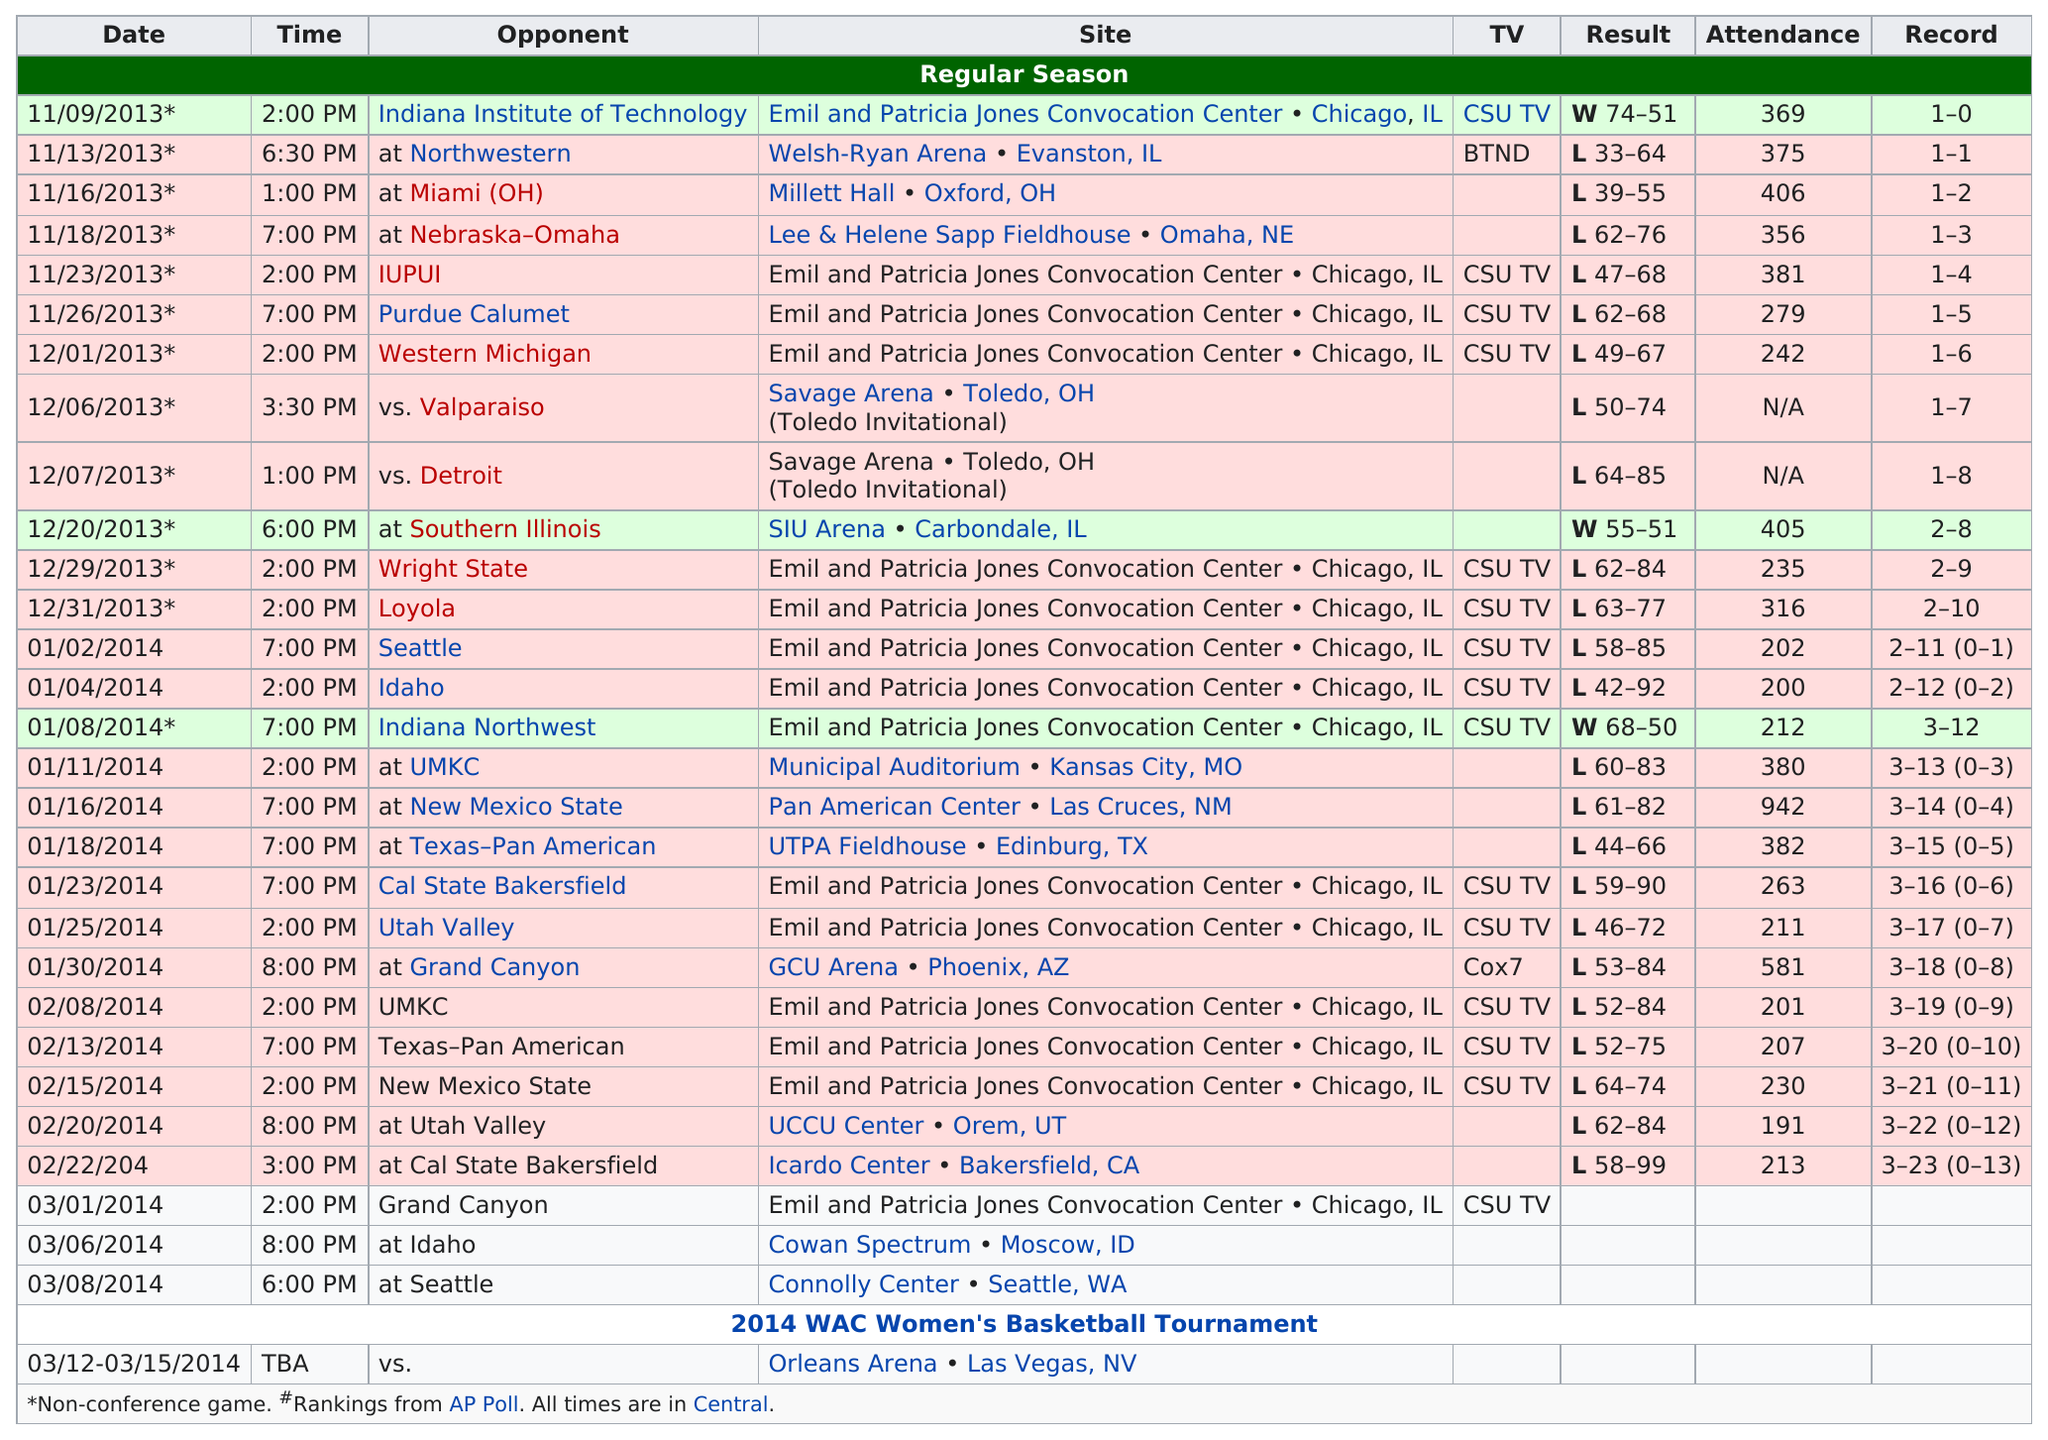Outline some significant characteristics in this image. The total attendance of the 11/09/2013 game was 369. The total attendance on November 9, 2013, plus the attendance of the game on November 23, 2013, was 750. On December 1st, 2013, a total of 242 people attended the game. There have been a total of 11 games with at least 300 people in attendance. The attendance was highest on January 16, 2014. 